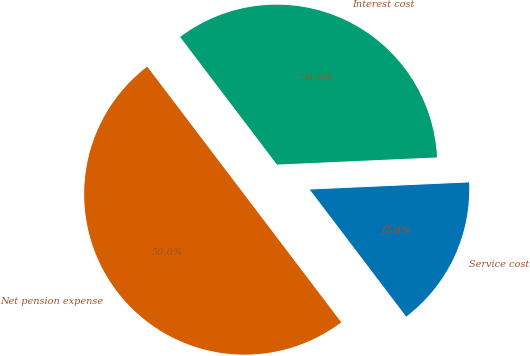<chart> <loc_0><loc_0><loc_500><loc_500><pie_chart><fcel>Service cost<fcel>Interest cost<fcel>Net pension expense<nl><fcel>15.38%<fcel>34.62%<fcel>50.0%<nl></chart> 